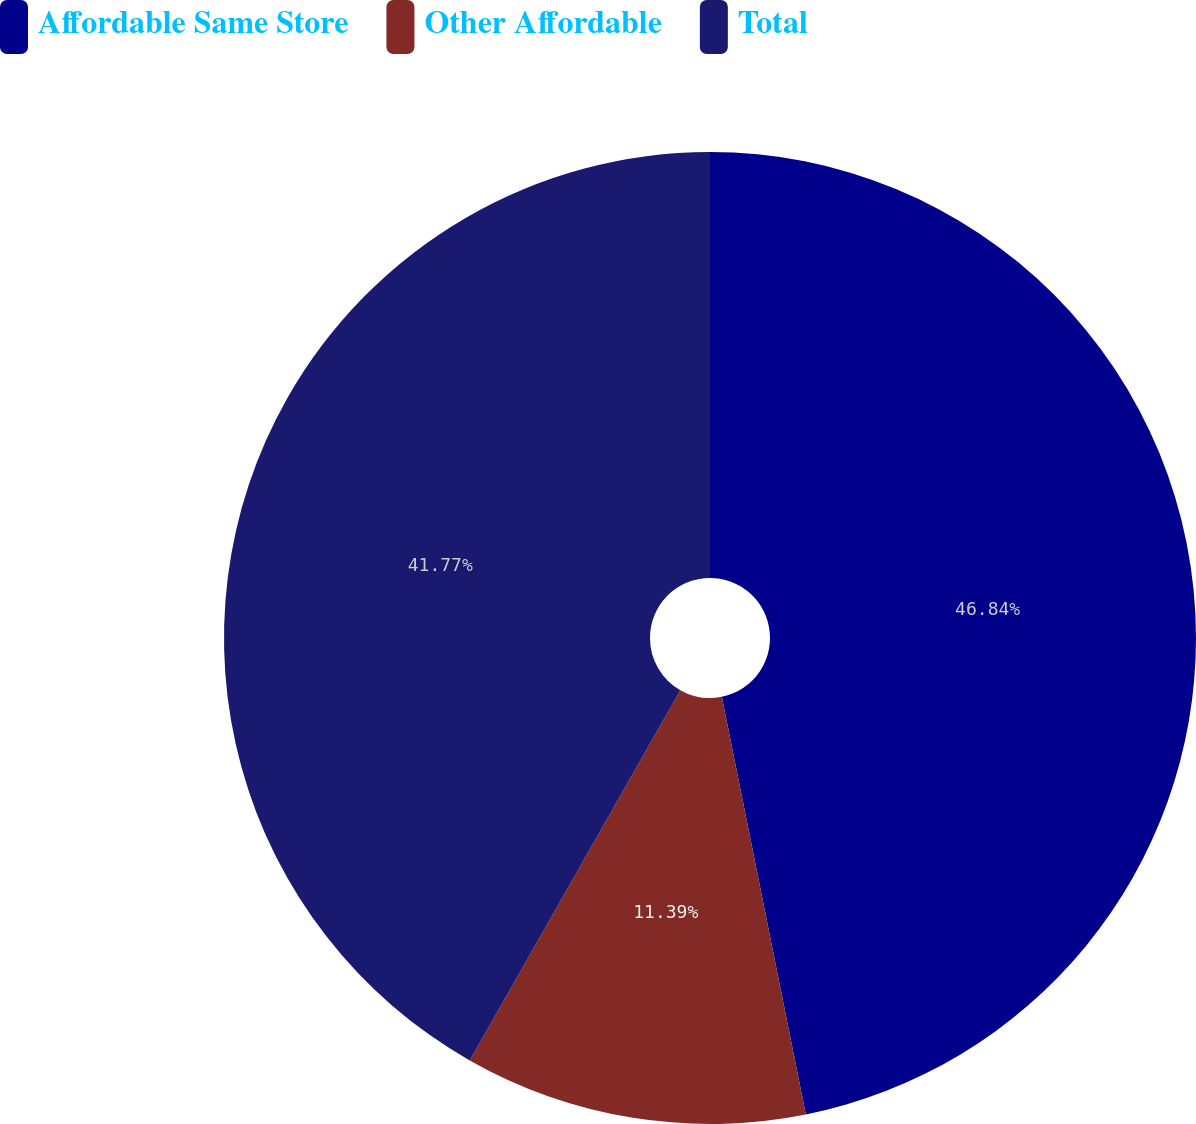<chart> <loc_0><loc_0><loc_500><loc_500><pie_chart><fcel>Affordable Same Store<fcel>Other Affordable<fcel>Total<nl><fcel>46.84%<fcel>11.39%<fcel>41.77%<nl></chart> 